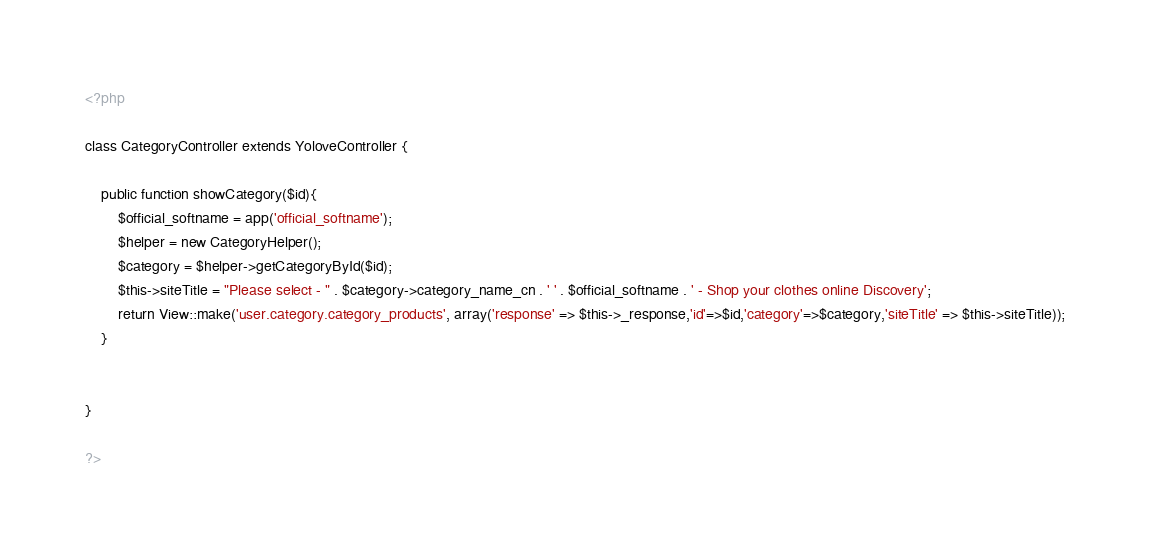Convert code to text. <code><loc_0><loc_0><loc_500><loc_500><_PHP_><?php

class CategoryController extends YoloveController {

    public function showCategory($id){
        $official_softname = app('official_softname');
        $helper = new CategoryHelper();
        $category = $helper->getCategoryById($id);
        $this->siteTitle = "Please select - " . $category->category_name_cn . ' ' . $official_softname . ' - Shop your clothes online Discovery'; 
        return View::make('user.category.category_products', array('response' => $this->_response,'id'=>$id,'category'=>$category,'siteTitle' => $this->siteTitle));
    }


}

?>
</code> 